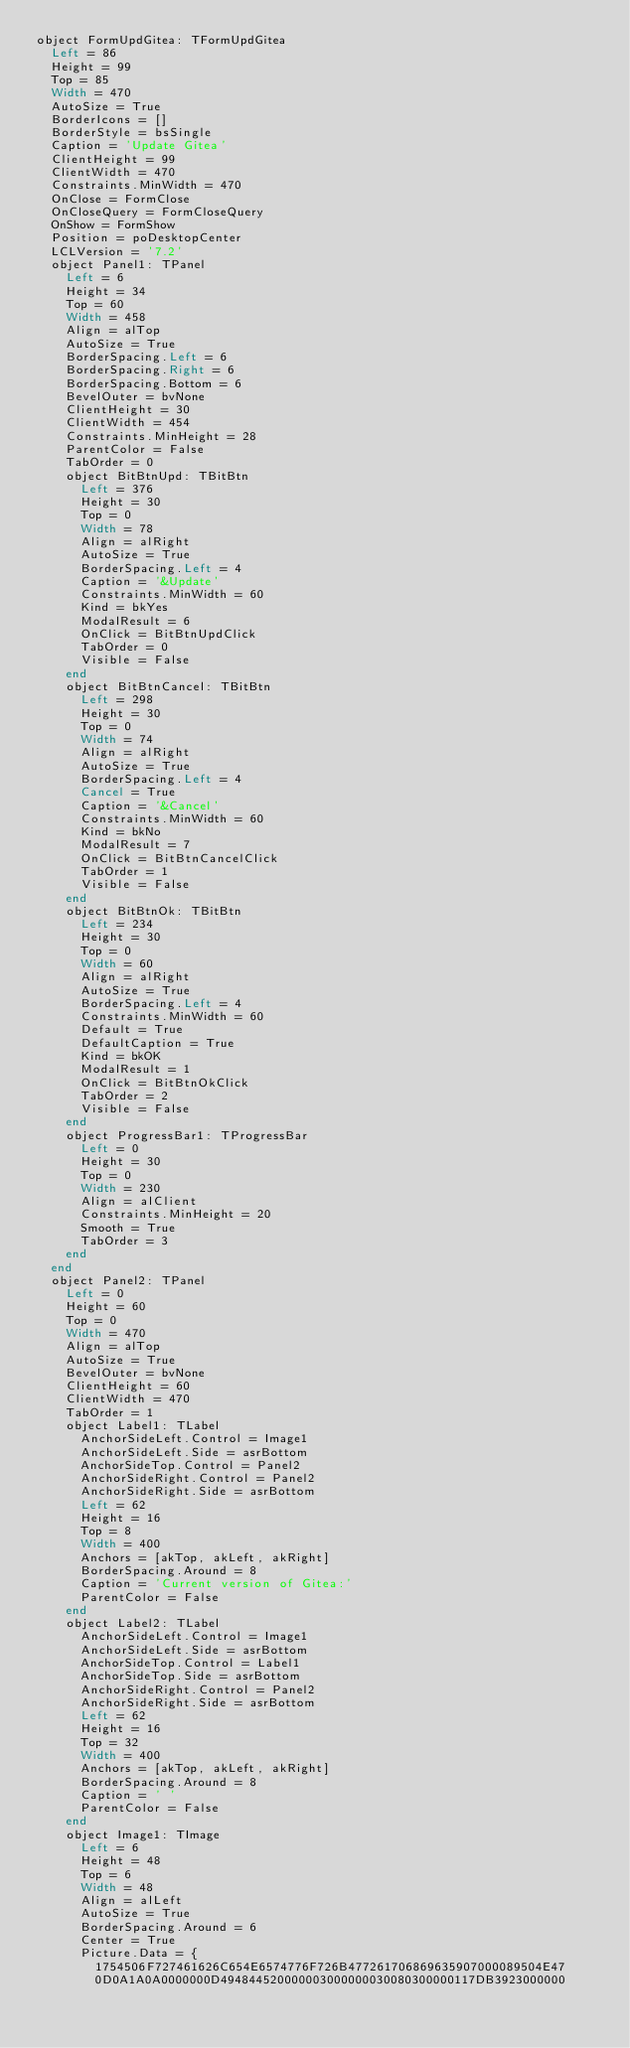Convert code to text. <code><loc_0><loc_0><loc_500><loc_500><_VisualBasic_>object FormUpdGitea: TFormUpdGitea
  Left = 86
  Height = 99
  Top = 85
  Width = 470
  AutoSize = True
  BorderIcons = []
  BorderStyle = bsSingle
  Caption = 'Update Gitea'
  ClientHeight = 99
  ClientWidth = 470
  Constraints.MinWidth = 470
  OnClose = FormClose
  OnCloseQuery = FormCloseQuery
  OnShow = FormShow
  Position = poDesktopCenter
  LCLVersion = '7.2'
  object Panel1: TPanel
    Left = 6
    Height = 34
    Top = 60
    Width = 458
    Align = alTop
    AutoSize = True
    BorderSpacing.Left = 6
    BorderSpacing.Right = 6
    BorderSpacing.Bottom = 6
    BevelOuter = bvNone
    ClientHeight = 30
    ClientWidth = 454
    Constraints.MinHeight = 28
    ParentColor = False
    TabOrder = 0
    object BitBtnUpd: TBitBtn
      Left = 376
      Height = 30
      Top = 0
      Width = 78
      Align = alRight
      AutoSize = True
      BorderSpacing.Left = 4
      Caption = '&Update'
      Constraints.MinWidth = 60
      Kind = bkYes
      ModalResult = 6
      OnClick = BitBtnUpdClick
      TabOrder = 0
      Visible = False
    end
    object BitBtnCancel: TBitBtn
      Left = 298
      Height = 30
      Top = 0
      Width = 74
      Align = alRight
      AutoSize = True
      BorderSpacing.Left = 4
      Cancel = True
      Caption = '&Cancel'
      Constraints.MinWidth = 60
      Kind = bkNo
      ModalResult = 7
      OnClick = BitBtnCancelClick
      TabOrder = 1
      Visible = False
    end
    object BitBtnOk: TBitBtn
      Left = 234
      Height = 30
      Top = 0
      Width = 60
      Align = alRight
      AutoSize = True
      BorderSpacing.Left = 4
      Constraints.MinWidth = 60
      Default = True
      DefaultCaption = True
      Kind = bkOK
      ModalResult = 1
      OnClick = BitBtnOkClick
      TabOrder = 2
      Visible = False
    end
    object ProgressBar1: TProgressBar
      Left = 0
      Height = 30
      Top = 0
      Width = 230
      Align = alClient
      Constraints.MinHeight = 20
      Smooth = True
      TabOrder = 3
    end
  end
  object Panel2: TPanel
    Left = 0
    Height = 60
    Top = 0
    Width = 470
    Align = alTop
    AutoSize = True
    BevelOuter = bvNone
    ClientHeight = 60
    ClientWidth = 470
    TabOrder = 1
    object Label1: TLabel
      AnchorSideLeft.Control = Image1
      AnchorSideLeft.Side = asrBottom
      AnchorSideTop.Control = Panel2
      AnchorSideRight.Control = Panel2
      AnchorSideRight.Side = asrBottom
      Left = 62
      Height = 16
      Top = 8
      Width = 400
      Anchors = [akTop, akLeft, akRight]
      BorderSpacing.Around = 8
      Caption = 'Current version of Gitea:'
      ParentColor = False
    end
    object Label2: TLabel
      AnchorSideLeft.Control = Image1
      AnchorSideLeft.Side = asrBottom
      AnchorSideTop.Control = Label1
      AnchorSideTop.Side = asrBottom
      AnchorSideRight.Control = Panel2
      AnchorSideRight.Side = asrBottom
      Left = 62
      Height = 16
      Top = 32
      Width = 400
      Anchors = [akTop, akLeft, akRight]
      BorderSpacing.Around = 8
      Caption = ' '
      ParentColor = False
    end
    object Image1: TImage
      Left = 6
      Height = 48
      Top = 6
      Width = 48
      Align = alLeft
      AutoSize = True
      BorderSpacing.Around = 6
      Center = True
      Picture.Data = {
        1754506F727461626C654E6574776F726B477261706869635907000089504E47
        0D0A1A0A0000000D494844520000003000000030080300000117DB3923000000</code> 